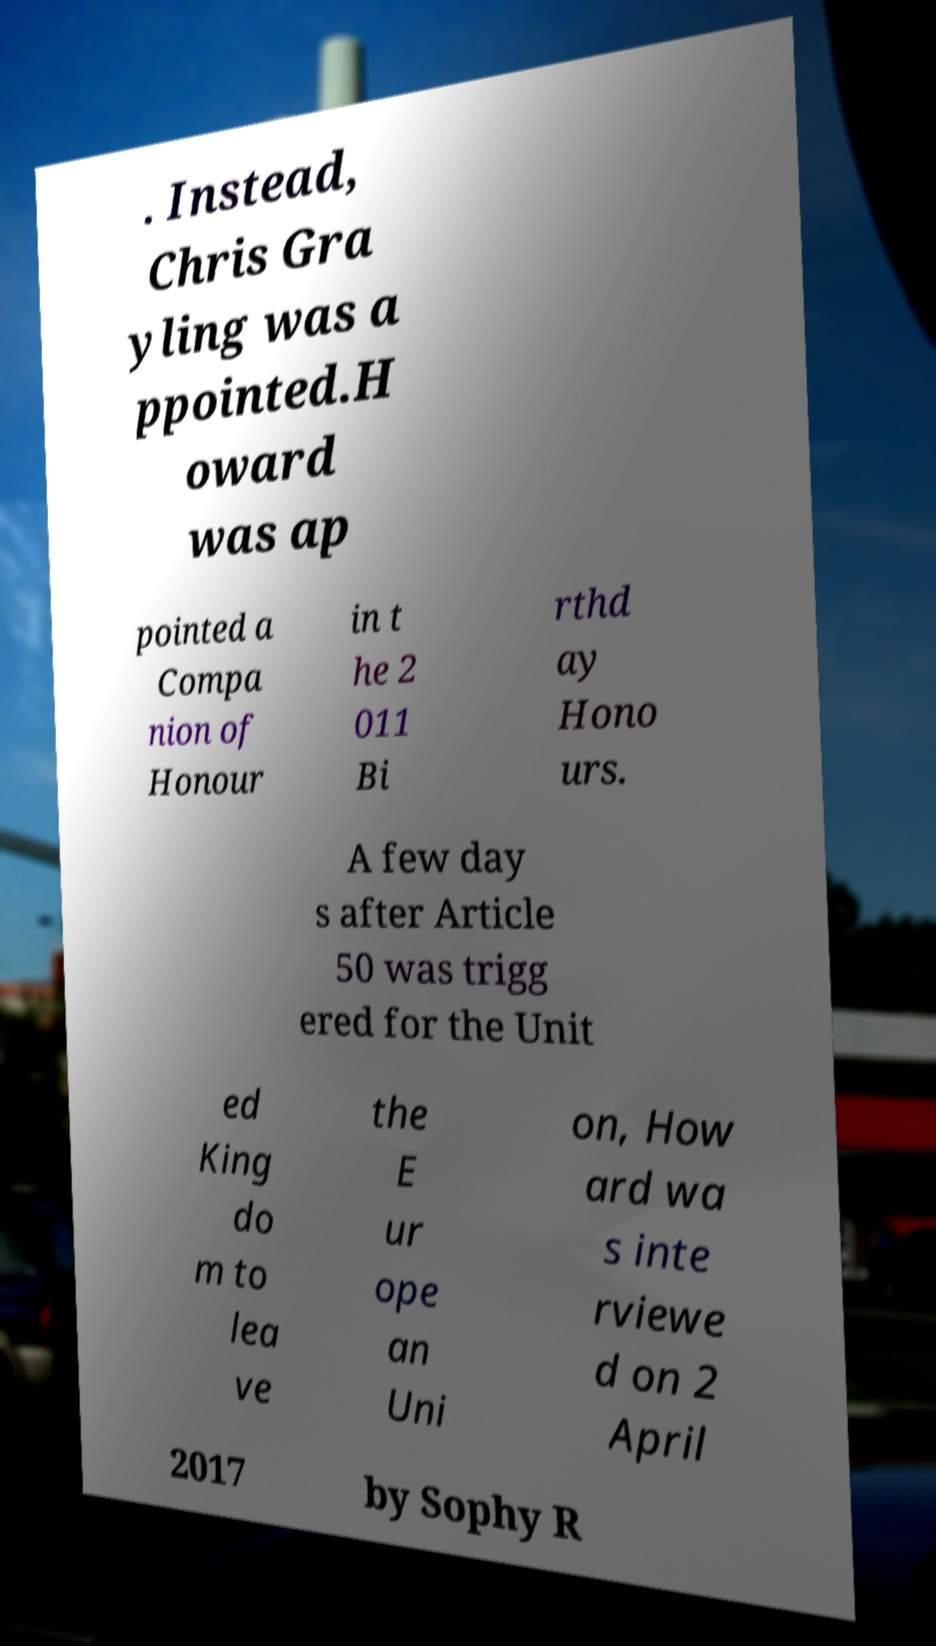Please read and relay the text visible in this image. What does it say? . Instead, Chris Gra yling was a ppointed.H oward was ap pointed a Compa nion of Honour in t he 2 011 Bi rthd ay Hono urs. A few day s after Article 50 was trigg ered for the Unit ed King do m to lea ve the E ur ope an Uni on, How ard wa s inte rviewe d on 2 April 2017 by Sophy R 